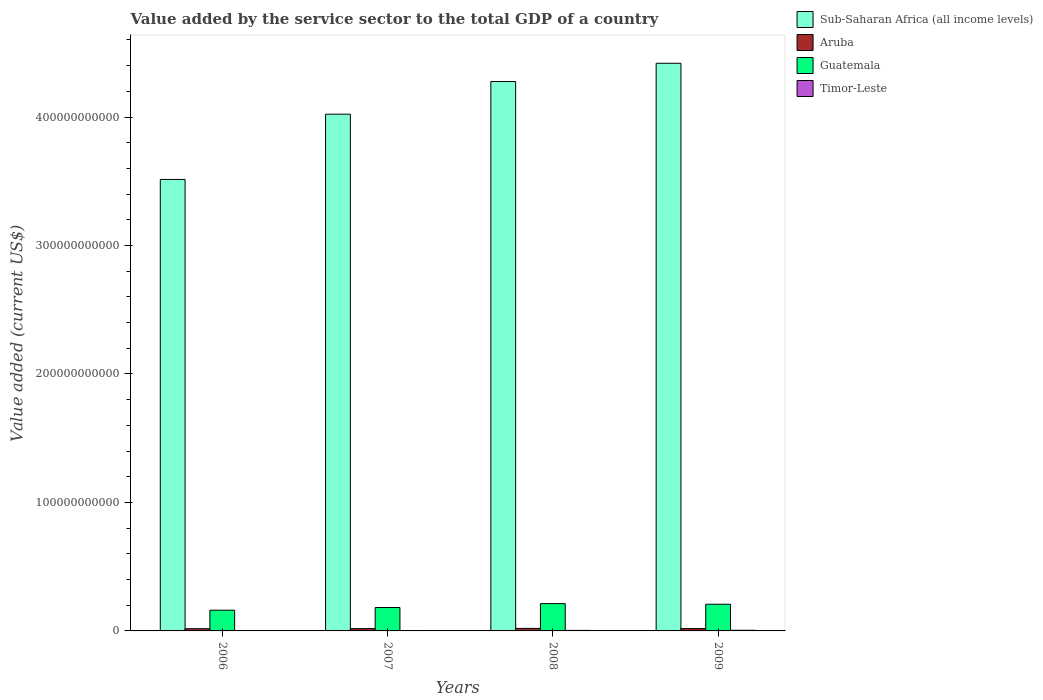How many groups of bars are there?
Offer a terse response. 4. Are the number of bars per tick equal to the number of legend labels?
Offer a terse response. Yes. What is the label of the 3rd group of bars from the left?
Ensure brevity in your answer.  2008. In how many cases, is the number of bars for a given year not equal to the number of legend labels?
Your answer should be very brief. 0. What is the value added by the service sector to the total GDP in Timor-Leste in 2009?
Ensure brevity in your answer.  5.11e+08. Across all years, what is the maximum value added by the service sector to the total GDP in Aruba?
Your response must be concise. 1.95e+09. Across all years, what is the minimum value added by the service sector to the total GDP in Sub-Saharan Africa (all income levels)?
Provide a short and direct response. 3.51e+11. What is the total value added by the service sector to the total GDP in Guatemala in the graph?
Give a very brief answer. 7.64e+1. What is the difference between the value added by the service sector to the total GDP in Timor-Leste in 2006 and that in 2008?
Provide a short and direct response. -1.33e+08. What is the difference between the value added by the service sector to the total GDP in Timor-Leste in 2007 and the value added by the service sector to the total GDP in Aruba in 2008?
Provide a succinct answer. -1.61e+09. What is the average value added by the service sector to the total GDP in Aruba per year?
Your response must be concise. 1.82e+09. In the year 2008, what is the difference between the value added by the service sector to the total GDP in Timor-Leste and value added by the service sector to the total GDP in Aruba?
Offer a terse response. -1.53e+09. What is the ratio of the value added by the service sector to the total GDP in Sub-Saharan Africa (all income levels) in 2006 to that in 2008?
Keep it short and to the point. 0.82. Is the difference between the value added by the service sector to the total GDP in Timor-Leste in 2006 and 2007 greater than the difference between the value added by the service sector to the total GDP in Aruba in 2006 and 2007?
Offer a very short reply. Yes. What is the difference between the highest and the second highest value added by the service sector to the total GDP in Aruba?
Your response must be concise. 1.20e+08. What is the difference between the highest and the lowest value added by the service sector to the total GDP in Aruba?
Provide a succinct answer. 2.39e+08. Is the sum of the value added by the service sector to the total GDP in Sub-Saharan Africa (all income levels) in 2007 and 2008 greater than the maximum value added by the service sector to the total GDP in Timor-Leste across all years?
Offer a very short reply. Yes. Is it the case that in every year, the sum of the value added by the service sector to the total GDP in Guatemala and value added by the service sector to the total GDP in Timor-Leste is greater than the sum of value added by the service sector to the total GDP in Aruba and value added by the service sector to the total GDP in Sub-Saharan Africa (all income levels)?
Give a very brief answer. Yes. What does the 3rd bar from the left in 2006 represents?
Ensure brevity in your answer.  Guatemala. What does the 3rd bar from the right in 2006 represents?
Your response must be concise. Aruba. How many bars are there?
Provide a succinct answer. 16. Are all the bars in the graph horizontal?
Give a very brief answer. No. How many years are there in the graph?
Give a very brief answer. 4. What is the difference between two consecutive major ticks on the Y-axis?
Provide a succinct answer. 1.00e+11. Does the graph contain grids?
Make the answer very short. No. Where does the legend appear in the graph?
Your answer should be compact. Top right. How many legend labels are there?
Provide a succinct answer. 4. How are the legend labels stacked?
Make the answer very short. Vertical. What is the title of the graph?
Ensure brevity in your answer.  Value added by the service sector to the total GDP of a country. Does "Tunisia" appear as one of the legend labels in the graph?
Offer a very short reply. No. What is the label or title of the X-axis?
Make the answer very short. Years. What is the label or title of the Y-axis?
Ensure brevity in your answer.  Value added (current US$). What is the Value added (current US$) in Sub-Saharan Africa (all income levels) in 2006?
Make the answer very short. 3.51e+11. What is the Value added (current US$) of Aruba in 2006?
Give a very brief answer. 1.71e+09. What is the Value added (current US$) of Guatemala in 2006?
Offer a very short reply. 1.61e+1. What is the Value added (current US$) in Timor-Leste in 2006?
Make the answer very short. 2.87e+08. What is the Value added (current US$) in Sub-Saharan Africa (all income levels) in 2007?
Give a very brief answer. 4.02e+11. What is the Value added (current US$) in Aruba in 2007?
Provide a succinct answer. 1.80e+09. What is the Value added (current US$) in Guatemala in 2007?
Your response must be concise. 1.82e+1. What is the Value added (current US$) of Timor-Leste in 2007?
Offer a terse response. 3.40e+08. What is the Value added (current US$) of Sub-Saharan Africa (all income levels) in 2008?
Your response must be concise. 4.28e+11. What is the Value added (current US$) in Aruba in 2008?
Your answer should be very brief. 1.95e+09. What is the Value added (current US$) in Guatemala in 2008?
Provide a short and direct response. 2.13e+1. What is the Value added (current US$) of Timor-Leste in 2008?
Your answer should be compact. 4.20e+08. What is the Value added (current US$) of Sub-Saharan Africa (all income levels) in 2009?
Offer a terse response. 4.42e+11. What is the Value added (current US$) of Aruba in 2009?
Your answer should be very brief. 1.83e+09. What is the Value added (current US$) of Guatemala in 2009?
Provide a short and direct response. 2.08e+1. What is the Value added (current US$) in Timor-Leste in 2009?
Your answer should be very brief. 5.11e+08. Across all years, what is the maximum Value added (current US$) of Sub-Saharan Africa (all income levels)?
Your response must be concise. 4.42e+11. Across all years, what is the maximum Value added (current US$) of Aruba?
Offer a terse response. 1.95e+09. Across all years, what is the maximum Value added (current US$) in Guatemala?
Make the answer very short. 2.13e+1. Across all years, what is the maximum Value added (current US$) of Timor-Leste?
Provide a short and direct response. 5.11e+08. Across all years, what is the minimum Value added (current US$) of Sub-Saharan Africa (all income levels)?
Your answer should be compact. 3.51e+11. Across all years, what is the minimum Value added (current US$) of Aruba?
Your answer should be very brief. 1.71e+09. Across all years, what is the minimum Value added (current US$) of Guatemala?
Provide a succinct answer. 1.61e+1. Across all years, what is the minimum Value added (current US$) of Timor-Leste?
Ensure brevity in your answer.  2.87e+08. What is the total Value added (current US$) of Sub-Saharan Africa (all income levels) in the graph?
Ensure brevity in your answer.  1.62e+12. What is the total Value added (current US$) in Aruba in the graph?
Your response must be concise. 7.29e+09. What is the total Value added (current US$) of Guatemala in the graph?
Provide a short and direct response. 7.64e+1. What is the total Value added (current US$) of Timor-Leste in the graph?
Offer a very short reply. 1.56e+09. What is the difference between the Value added (current US$) in Sub-Saharan Africa (all income levels) in 2006 and that in 2007?
Make the answer very short. -5.08e+1. What is the difference between the Value added (current US$) in Aruba in 2006 and that in 2007?
Ensure brevity in your answer.  -9.01e+07. What is the difference between the Value added (current US$) in Guatemala in 2006 and that in 2007?
Your answer should be very brief. -2.09e+09. What is the difference between the Value added (current US$) of Timor-Leste in 2006 and that in 2007?
Your response must be concise. -5.30e+07. What is the difference between the Value added (current US$) in Sub-Saharan Africa (all income levels) in 2006 and that in 2008?
Your answer should be compact. -7.62e+1. What is the difference between the Value added (current US$) in Aruba in 2006 and that in 2008?
Keep it short and to the point. -2.39e+08. What is the difference between the Value added (current US$) in Guatemala in 2006 and that in 2008?
Offer a terse response. -5.13e+09. What is the difference between the Value added (current US$) in Timor-Leste in 2006 and that in 2008?
Ensure brevity in your answer.  -1.33e+08. What is the difference between the Value added (current US$) of Sub-Saharan Africa (all income levels) in 2006 and that in 2009?
Ensure brevity in your answer.  -9.04e+1. What is the difference between the Value added (current US$) in Aruba in 2006 and that in 2009?
Offer a very short reply. -1.19e+08. What is the difference between the Value added (current US$) of Guatemala in 2006 and that in 2009?
Ensure brevity in your answer.  -4.64e+09. What is the difference between the Value added (current US$) of Timor-Leste in 2006 and that in 2009?
Keep it short and to the point. -2.24e+08. What is the difference between the Value added (current US$) in Sub-Saharan Africa (all income levels) in 2007 and that in 2008?
Your response must be concise. -2.54e+1. What is the difference between the Value added (current US$) in Aruba in 2007 and that in 2008?
Offer a terse response. -1.49e+08. What is the difference between the Value added (current US$) in Guatemala in 2007 and that in 2008?
Provide a succinct answer. -3.04e+09. What is the difference between the Value added (current US$) in Timor-Leste in 2007 and that in 2008?
Keep it short and to the point. -8.00e+07. What is the difference between the Value added (current US$) of Sub-Saharan Africa (all income levels) in 2007 and that in 2009?
Your answer should be very brief. -3.96e+1. What is the difference between the Value added (current US$) in Aruba in 2007 and that in 2009?
Make the answer very short. -2.88e+07. What is the difference between the Value added (current US$) in Guatemala in 2007 and that in 2009?
Provide a succinct answer. -2.55e+09. What is the difference between the Value added (current US$) of Timor-Leste in 2007 and that in 2009?
Provide a succinct answer. -1.71e+08. What is the difference between the Value added (current US$) of Sub-Saharan Africa (all income levels) in 2008 and that in 2009?
Provide a succinct answer. -1.42e+1. What is the difference between the Value added (current US$) of Aruba in 2008 and that in 2009?
Make the answer very short. 1.20e+08. What is the difference between the Value added (current US$) in Guatemala in 2008 and that in 2009?
Provide a short and direct response. 4.86e+08. What is the difference between the Value added (current US$) in Timor-Leste in 2008 and that in 2009?
Offer a terse response. -9.10e+07. What is the difference between the Value added (current US$) in Sub-Saharan Africa (all income levels) in 2006 and the Value added (current US$) in Aruba in 2007?
Give a very brief answer. 3.50e+11. What is the difference between the Value added (current US$) in Sub-Saharan Africa (all income levels) in 2006 and the Value added (current US$) in Guatemala in 2007?
Provide a short and direct response. 3.33e+11. What is the difference between the Value added (current US$) in Sub-Saharan Africa (all income levels) in 2006 and the Value added (current US$) in Timor-Leste in 2007?
Offer a terse response. 3.51e+11. What is the difference between the Value added (current US$) of Aruba in 2006 and the Value added (current US$) of Guatemala in 2007?
Your answer should be compact. -1.65e+1. What is the difference between the Value added (current US$) of Aruba in 2006 and the Value added (current US$) of Timor-Leste in 2007?
Your response must be concise. 1.37e+09. What is the difference between the Value added (current US$) of Guatemala in 2006 and the Value added (current US$) of Timor-Leste in 2007?
Give a very brief answer. 1.58e+1. What is the difference between the Value added (current US$) in Sub-Saharan Africa (all income levels) in 2006 and the Value added (current US$) in Aruba in 2008?
Your answer should be very brief. 3.49e+11. What is the difference between the Value added (current US$) in Sub-Saharan Africa (all income levels) in 2006 and the Value added (current US$) in Guatemala in 2008?
Provide a succinct answer. 3.30e+11. What is the difference between the Value added (current US$) in Sub-Saharan Africa (all income levels) in 2006 and the Value added (current US$) in Timor-Leste in 2008?
Make the answer very short. 3.51e+11. What is the difference between the Value added (current US$) of Aruba in 2006 and the Value added (current US$) of Guatemala in 2008?
Provide a short and direct response. -1.95e+1. What is the difference between the Value added (current US$) in Aruba in 2006 and the Value added (current US$) in Timor-Leste in 2008?
Provide a succinct answer. 1.29e+09. What is the difference between the Value added (current US$) in Guatemala in 2006 and the Value added (current US$) in Timor-Leste in 2008?
Offer a terse response. 1.57e+1. What is the difference between the Value added (current US$) of Sub-Saharan Africa (all income levels) in 2006 and the Value added (current US$) of Aruba in 2009?
Ensure brevity in your answer.  3.50e+11. What is the difference between the Value added (current US$) of Sub-Saharan Africa (all income levels) in 2006 and the Value added (current US$) of Guatemala in 2009?
Provide a short and direct response. 3.31e+11. What is the difference between the Value added (current US$) of Sub-Saharan Africa (all income levels) in 2006 and the Value added (current US$) of Timor-Leste in 2009?
Ensure brevity in your answer.  3.51e+11. What is the difference between the Value added (current US$) in Aruba in 2006 and the Value added (current US$) in Guatemala in 2009?
Provide a succinct answer. -1.91e+1. What is the difference between the Value added (current US$) in Aruba in 2006 and the Value added (current US$) in Timor-Leste in 2009?
Provide a short and direct response. 1.20e+09. What is the difference between the Value added (current US$) of Guatemala in 2006 and the Value added (current US$) of Timor-Leste in 2009?
Provide a short and direct response. 1.56e+1. What is the difference between the Value added (current US$) in Sub-Saharan Africa (all income levels) in 2007 and the Value added (current US$) in Aruba in 2008?
Provide a short and direct response. 4.00e+11. What is the difference between the Value added (current US$) of Sub-Saharan Africa (all income levels) in 2007 and the Value added (current US$) of Guatemala in 2008?
Provide a succinct answer. 3.81e+11. What is the difference between the Value added (current US$) of Sub-Saharan Africa (all income levels) in 2007 and the Value added (current US$) of Timor-Leste in 2008?
Your response must be concise. 4.02e+11. What is the difference between the Value added (current US$) of Aruba in 2007 and the Value added (current US$) of Guatemala in 2008?
Offer a very short reply. -1.95e+1. What is the difference between the Value added (current US$) of Aruba in 2007 and the Value added (current US$) of Timor-Leste in 2008?
Offer a terse response. 1.38e+09. What is the difference between the Value added (current US$) in Guatemala in 2007 and the Value added (current US$) in Timor-Leste in 2008?
Keep it short and to the point. 1.78e+1. What is the difference between the Value added (current US$) of Sub-Saharan Africa (all income levels) in 2007 and the Value added (current US$) of Aruba in 2009?
Offer a very short reply. 4.00e+11. What is the difference between the Value added (current US$) in Sub-Saharan Africa (all income levels) in 2007 and the Value added (current US$) in Guatemala in 2009?
Ensure brevity in your answer.  3.81e+11. What is the difference between the Value added (current US$) of Sub-Saharan Africa (all income levels) in 2007 and the Value added (current US$) of Timor-Leste in 2009?
Offer a very short reply. 4.02e+11. What is the difference between the Value added (current US$) of Aruba in 2007 and the Value added (current US$) of Guatemala in 2009?
Give a very brief answer. -1.90e+1. What is the difference between the Value added (current US$) in Aruba in 2007 and the Value added (current US$) in Timor-Leste in 2009?
Give a very brief answer. 1.29e+09. What is the difference between the Value added (current US$) of Guatemala in 2007 and the Value added (current US$) of Timor-Leste in 2009?
Your answer should be very brief. 1.77e+1. What is the difference between the Value added (current US$) of Sub-Saharan Africa (all income levels) in 2008 and the Value added (current US$) of Aruba in 2009?
Make the answer very short. 4.26e+11. What is the difference between the Value added (current US$) in Sub-Saharan Africa (all income levels) in 2008 and the Value added (current US$) in Guatemala in 2009?
Your answer should be very brief. 4.07e+11. What is the difference between the Value added (current US$) of Sub-Saharan Africa (all income levels) in 2008 and the Value added (current US$) of Timor-Leste in 2009?
Offer a very short reply. 4.27e+11. What is the difference between the Value added (current US$) of Aruba in 2008 and the Value added (current US$) of Guatemala in 2009?
Keep it short and to the point. -1.88e+1. What is the difference between the Value added (current US$) in Aruba in 2008 and the Value added (current US$) in Timor-Leste in 2009?
Provide a succinct answer. 1.44e+09. What is the difference between the Value added (current US$) of Guatemala in 2008 and the Value added (current US$) of Timor-Leste in 2009?
Your response must be concise. 2.07e+1. What is the average Value added (current US$) of Sub-Saharan Africa (all income levels) per year?
Ensure brevity in your answer.  4.06e+11. What is the average Value added (current US$) of Aruba per year?
Provide a short and direct response. 1.82e+09. What is the average Value added (current US$) in Guatemala per year?
Keep it short and to the point. 1.91e+1. What is the average Value added (current US$) in Timor-Leste per year?
Provide a succinct answer. 3.90e+08. In the year 2006, what is the difference between the Value added (current US$) in Sub-Saharan Africa (all income levels) and Value added (current US$) in Aruba?
Provide a succinct answer. 3.50e+11. In the year 2006, what is the difference between the Value added (current US$) of Sub-Saharan Africa (all income levels) and Value added (current US$) of Guatemala?
Provide a succinct answer. 3.35e+11. In the year 2006, what is the difference between the Value added (current US$) in Sub-Saharan Africa (all income levels) and Value added (current US$) in Timor-Leste?
Your answer should be compact. 3.51e+11. In the year 2006, what is the difference between the Value added (current US$) of Aruba and Value added (current US$) of Guatemala?
Keep it short and to the point. -1.44e+1. In the year 2006, what is the difference between the Value added (current US$) of Aruba and Value added (current US$) of Timor-Leste?
Provide a succinct answer. 1.42e+09. In the year 2006, what is the difference between the Value added (current US$) of Guatemala and Value added (current US$) of Timor-Leste?
Provide a short and direct response. 1.58e+1. In the year 2007, what is the difference between the Value added (current US$) in Sub-Saharan Africa (all income levels) and Value added (current US$) in Aruba?
Ensure brevity in your answer.  4.00e+11. In the year 2007, what is the difference between the Value added (current US$) of Sub-Saharan Africa (all income levels) and Value added (current US$) of Guatemala?
Ensure brevity in your answer.  3.84e+11. In the year 2007, what is the difference between the Value added (current US$) of Sub-Saharan Africa (all income levels) and Value added (current US$) of Timor-Leste?
Provide a succinct answer. 4.02e+11. In the year 2007, what is the difference between the Value added (current US$) of Aruba and Value added (current US$) of Guatemala?
Your answer should be compact. -1.64e+1. In the year 2007, what is the difference between the Value added (current US$) of Aruba and Value added (current US$) of Timor-Leste?
Your answer should be very brief. 1.46e+09. In the year 2007, what is the difference between the Value added (current US$) of Guatemala and Value added (current US$) of Timor-Leste?
Your answer should be compact. 1.79e+1. In the year 2008, what is the difference between the Value added (current US$) of Sub-Saharan Africa (all income levels) and Value added (current US$) of Aruba?
Keep it short and to the point. 4.26e+11. In the year 2008, what is the difference between the Value added (current US$) in Sub-Saharan Africa (all income levels) and Value added (current US$) in Guatemala?
Ensure brevity in your answer.  4.06e+11. In the year 2008, what is the difference between the Value added (current US$) in Sub-Saharan Africa (all income levels) and Value added (current US$) in Timor-Leste?
Give a very brief answer. 4.27e+11. In the year 2008, what is the difference between the Value added (current US$) in Aruba and Value added (current US$) in Guatemala?
Your answer should be very brief. -1.93e+1. In the year 2008, what is the difference between the Value added (current US$) of Aruba and Value added (current US$) of Timor-Leste?
Offer a very short reply. 1.53e+09. In the year 2008, what is the difference between the Value added (current US$) of Guatemala and Value added (current US$) of Timor-Leste?
Your answer should be compact. 2.08e+1. In the year 2009, what is the difference between the Value added (current US$) of Sub-Saharan Africa (all income levels) and Value added (current US$) of Aruba?
Your answer should be very brief. 4.40e+11. In the year 2009, what is the difference between the Value added (current US$) of Sub-Saharan Africa (all income levels) and Value added (current US$) of Guatemala?
Your answer should be very brief. 4.21e+11. In the year 2009, what is the difference between the Value added (current US$) of Sub-Saharan Africa (all income levels) and Value added (current US$) of Timor-Leste?
Offer a very short reply. 4.41e+11. In the year 2009, what is the difference between the Value added (current US$) of Aruba and Value added (current US$) of Guatemala?
Give a very brief answer. -1.89e+1. In the year 2009, what is the difference between the Value added (current US$) in Aruba and Value added (current US$) in Timor-Leste?
Keep it short and to the point. 1.32e+09. In the year 2009, what is the difference between the Value added (current US$) of Guatemala and Value added (current US$) of Timor-Leste?
Your response must be concise. 2.03e+1. What is the ratio of the Value added (current US$) in Sub-Saharan Africa (all income levels) in 2006 to that in 2007?
Provide a succinct answer. 0.87. What is the ratio of the Value added (current US$) of Aruba in 2006 to that in 2007?
Provide a short and direct response. 0.95. What is the ratio of the Value added (current US$) of Guatemala in 2006 to that in 2007?
Offer a very short reply. 0.89. What is the ratio of the Value added (current US$) of Timor-Leste in 2006 to that in 2007?
Provide a short and direct response. 0.84. What is the ratio of the Value added (current US$) of Sub-Saharan Africa (all income levels) in 2006 to that in 2008?
Your response must be concise. 0.82. What is the ratio of the Value added (current US$) in Aruba in 2006 to that in 2008?
Your response must be concise. 0.88. What is the ratio of the Value added (current US$) in Guatemala in 2006 to that in 2008?
Make the answer very short. 0.76. What is the ratio of the Value added (current US$) of Timor-Leste in 2006 to that in 2008?
Provide a short and direct response. 0.68. What is the ratio of the Value added (current US$) in Sub-Saharan Africa (all income levels) in 2006 to that in 2009?
Provide a succinct answer. 0.8. What is the ratio of the Value added (current US$) in Aruba in 2006 to that in 2009?
Offer a terse response. 0.94. What is the ratio of the Value added (current US$) in Guatemala in 2006 to that in 2009?
Offer a terse response. 0.78. What is the ratio of the Value added (current US$) in Timor-Leste in 2006 to that in 2009?
Make the answer very short. 0.56. What is the ratio of the Value added (current US$) of Sub-Saharan Africa (all income levels) in 2007 to that in 2008?
Provide a succinct answer. 0.94. What is the ratio of the Value added (current US$) of Aruba in 2007 to that in 2008?
Offer a very short reply. 0.92. What is the ratio of the Value added (current US$) of Guatemala in 2007 to that in 2008?
Offer a very short reply. 0.86. What is the ratio of the Value added (current US$) of Timor-Leste in 2007 to that in 2008?
Provide a succinct answer. 0.81. What is the ratio of the Value added (current US$) in Sub-Saharan Africa (all income levels) in 2007 to that in 2009?
Keep it short and to the point. 0.91. What is the ratio of the Value added (current US$) in Aruba in 2007 to that in 2009?
Your response must be concise. 0.98. What is the ratio of the Value added (current US$) in Guatemala in 2007 to that in 2009?
Provide a short and direct response. 0.88. What is the ratio of the Value added (current US$) in Timor-Leste in 2007 to that in 2009?
Your answer should be compact. 0.67. What is the ratio of the Value added (current US$) in Sub-Saharan Africa (all income levels) in 2008 to that in 2009?
Provide a succinct answer. 0.97. What is the ratio of the Value added (current US$) in Aruba in 2008 to that in 2009?
Your answer should be very brief. 1.07. What is the ratio of the Value added (current US$) of Guatemala in 2008 to that in 2009?
Keep it short and to the point. 1.02. What is the ratio of the Value added (current US$) in Timor-Leste in 2008 to that in 2009?
Your response must be concise. 0.82. What is the difference between the highest and the second highest Value added (current US$) in Sub-Saharan Africa (all income levels)?
Ensure brevity in your answer.  1.42e+1. What is the difference between the highest and the second highest Value added (current US$) of Aruba?
Provide a short and direct response. 1.20e+08. What is the difference between the highest and the second highest Value added (current US$) of Guatemala?
Offer a very short reply. 4.86e+08. What is the difference between the highest and the second highest Value added (current US$) of Timor-Leste?
Ensure brevity in your answer.  9.10e+07. What is the difference between the highest and the lowest Value added (current US$) of Sub-Saharan Africa (all income levels)?
Give a very brief answer. 9.04e+1. What is the difference between the highest and the lowest Value added (current US$) in Aruba?
Offer a terse response. 2.39e+08. What is the difference between the highest and the lowest Value added (current US$) in Guatemala?
Provide a short and direct response. 5.13e+09. What is the difference between the highest and the lowest Value added (current US$) in Timor-Leste?
Your response must be concise. 2.24e+08. 